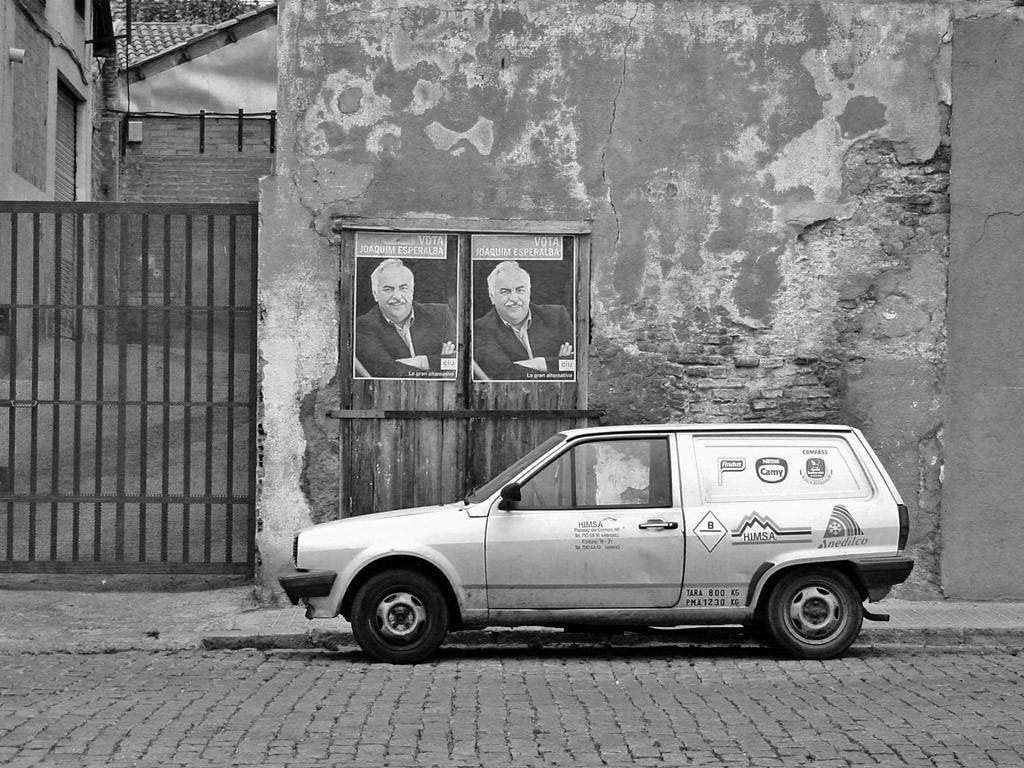How would you summarize this image in a sentence or two? In this picture we can see car on the surface, posters on the wooden door, wall, gate, building, shutter and roof top. 